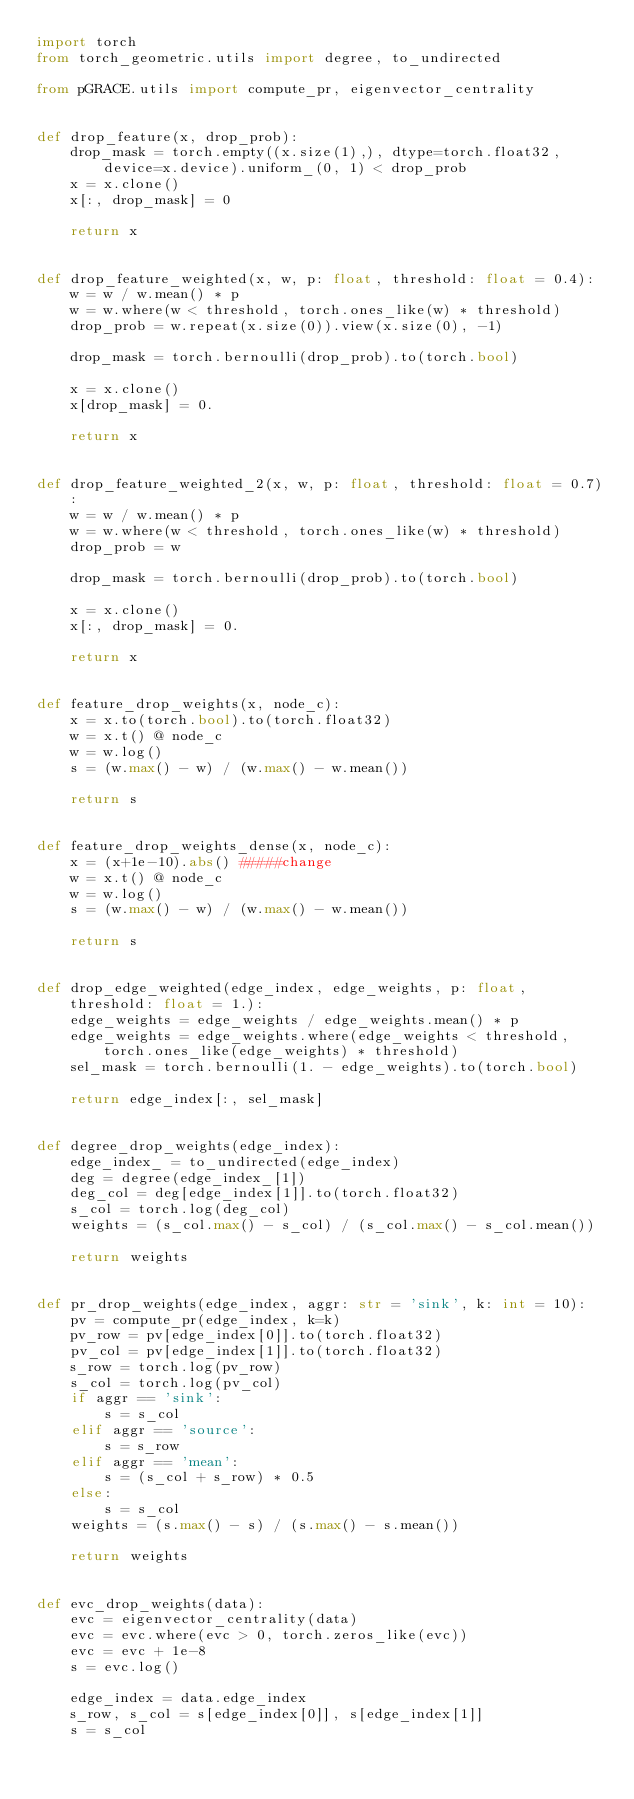Convert code to text. <code><loc_0><loc_0><loc_500><loc_500><_Python_>import torch
from torch_geometric.utils import degree, to_undirected

from pGRACE.utils import compute_pr, eigenvector_centrality


def drop_feature(x, drop_prob):
    drop_mask = torch.empty((x.size(1),), dtype=torch.float32, device=x.device).uniform_(0, 1) < drop_prob
    x = x.clone()
    x[:, drop_mask] = 0

    return x


def drop_feature_weighted(x, w, p: float, threshold: float = 0.4):
    w = w / w.mean() * p
    w = w.where(w < threshold, torch.ones_like(w) * threshold)
    drop_prob = w.repeat(x.size(0)).view(x.size(0), -1)

    drop_mask = torch.bernoulli(drop_prob).to(torch.bool)

    x = x.clone()
    x[drop_mask] = 0.

    return x


def drop_feature_weighted_2(x, w, p: float, threshold: float = 0.7):
    w = w / w.mean() * p
    w = w.where(w < threshold, torch.ones_like(w) * threshold)
    drop_prob = w

    drop_mask = torch.bernoulli(drop_prob).to(torch.bool)

    x = x.clone()
    x[:, drop_mask] = 0.

    return x


def feature_drop_weights(x, node_c):
    x = x.to(torch.bool).to(torch.float32)
    w = x.t() @ node_c
    w = w.log()
    s = (w.max() - w) / (w.max() - w.mean())

    return s


def feature_drop_weights_dense(x, node_c):
    x = (x+1e-10).abs() #####change
    w = x.t() @ node_c
    w = w.log()
    s = (w.max() - w) / (w.max() - w.mean())

    return s


def drop_edge_weighted(edge_index, edge_weights, p: float, threshold: float = 1.):
    edge_weights = edge_weights / edge_weights.mean() * p
    edge_weights = edge_weights.where(edge_weights < threshold, torch.ones_like(edge_weights) * threshold)
    sel_mask = torch.bernoulli(1. - edge_weights).to(torch.bool)

    return edge_index[:, sel_mask]


def degree_drop_weights(edge_index):
    edge_index_ = to_undirected(edge_index)
    deg = degree(edge_index_[1])
    deg_col = deg[edge_index[1]].to(torch.float32)
    s_col = torch.log(deg_col)
    weights = (s_col.max() - s_col) / (s_col.max() - s_col.mean())

    return weights


def pr_drop_weights(edge_index, aggr: str = 'sink', k: int = 10):
    pv = compute_pr(edge_index, k=k)
    pv_row = pv[edge_index[0]].to(torch.float32)
    pv_col = pv[edge_index[1]].to(torch.float32)
    s_row = torch.log(pv_row)
    s_col = torch.log(pv_col)
    if aggr == 'sink':
        s = s_col
    elif aggr == 'source':
        s = s_row
    elif aggr == 'mean':
        s = (s_col + s_row) * 0.5
    else:
        s = s_col
    weights = (s.max() - s) / (s.max() - s.mean())

    return weights


def evc_drop_weights(data):
    evc = eigenvector_centrality(data)
    evc = evc.where(evc > 0, torch.zeros_like(evc))
    evc = evc + 1e-8
    s = evc.log()

    edge_index = data.edge_index
    s_row, s_col = s[edge_index[0]], s[edge_index[1]]
    s = s_col
</code> 